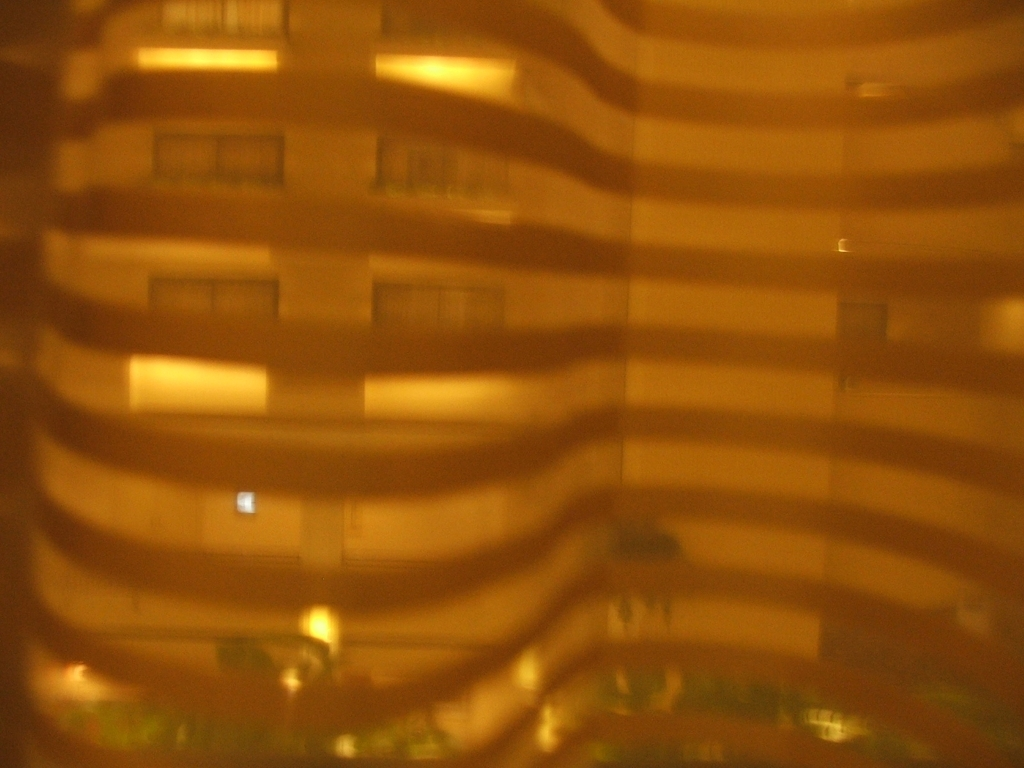Is the color accuracy good? The color accuracy in the image appears to be compromised, possibly due to low lighting conditions or an intentional effect like sepia toning, which results in a monochromatic color scheme that does not represent the true colors of the scene. 